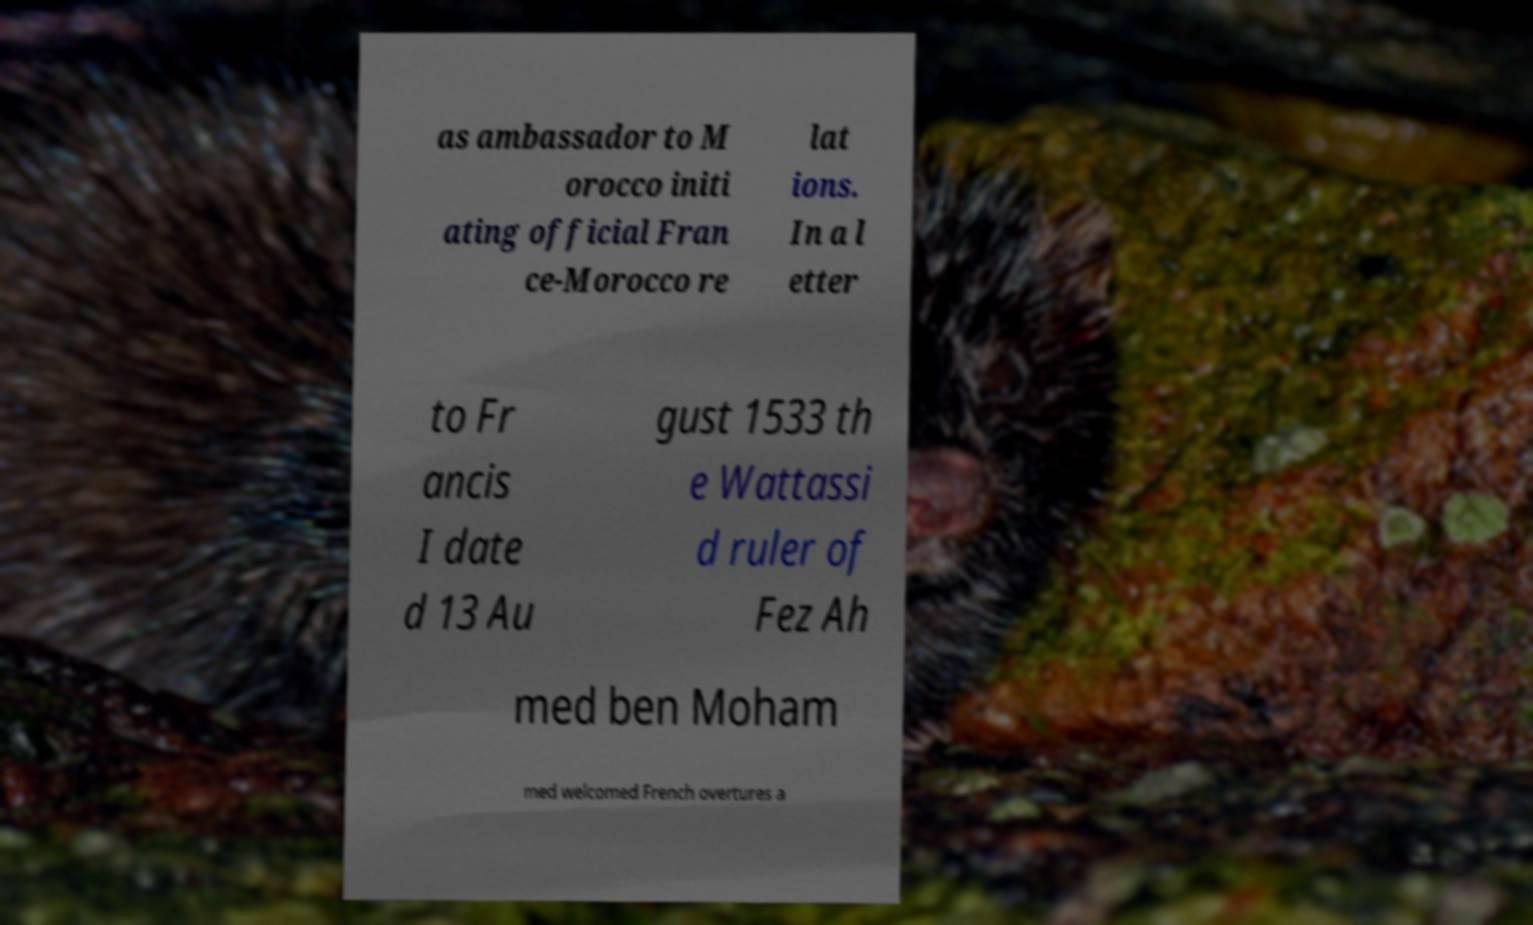Can you read and provide the text displayed in the image?This photo seems to have some interesting text. Can you extract and type it out for me? as ambassador to M orocco initi ating official Fran ce-Morocco re lat ions. In a l etter to Fr ancis I date d 13 Au gust 1533 th e Wattassi d ruler of Fez Ah med ben Moham med welcomed French overtures a 